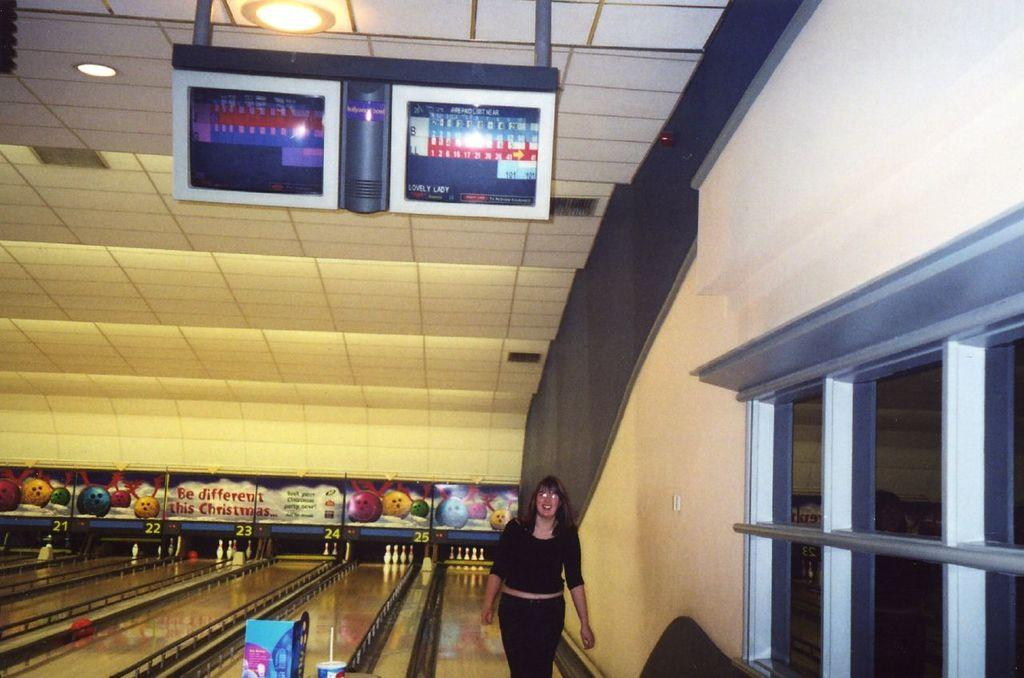What is the main subject of the image? There is a woman standing in the middle of the image. What is the woman's facial expression? The woman is smiling. What can be seen behind the woman? There is a wall behind the woman. What is visible at the top of the image? The ceiling, lights, and a screen are present at the top of the image. What type of question is the lawyer asking the woman in the image? There is no lawyer or question present in the image; it only features a woman standing and smiling. Can you tell me how many pears are on the screen at the top of the image? There are no pears visible on the screen at the top of the image. 